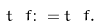Convert formula to latex. <formula><loc_0><loc_0><loc_500><loc_500>\ t _ { \ } f \colon = t _ { \ } f .</formula> 